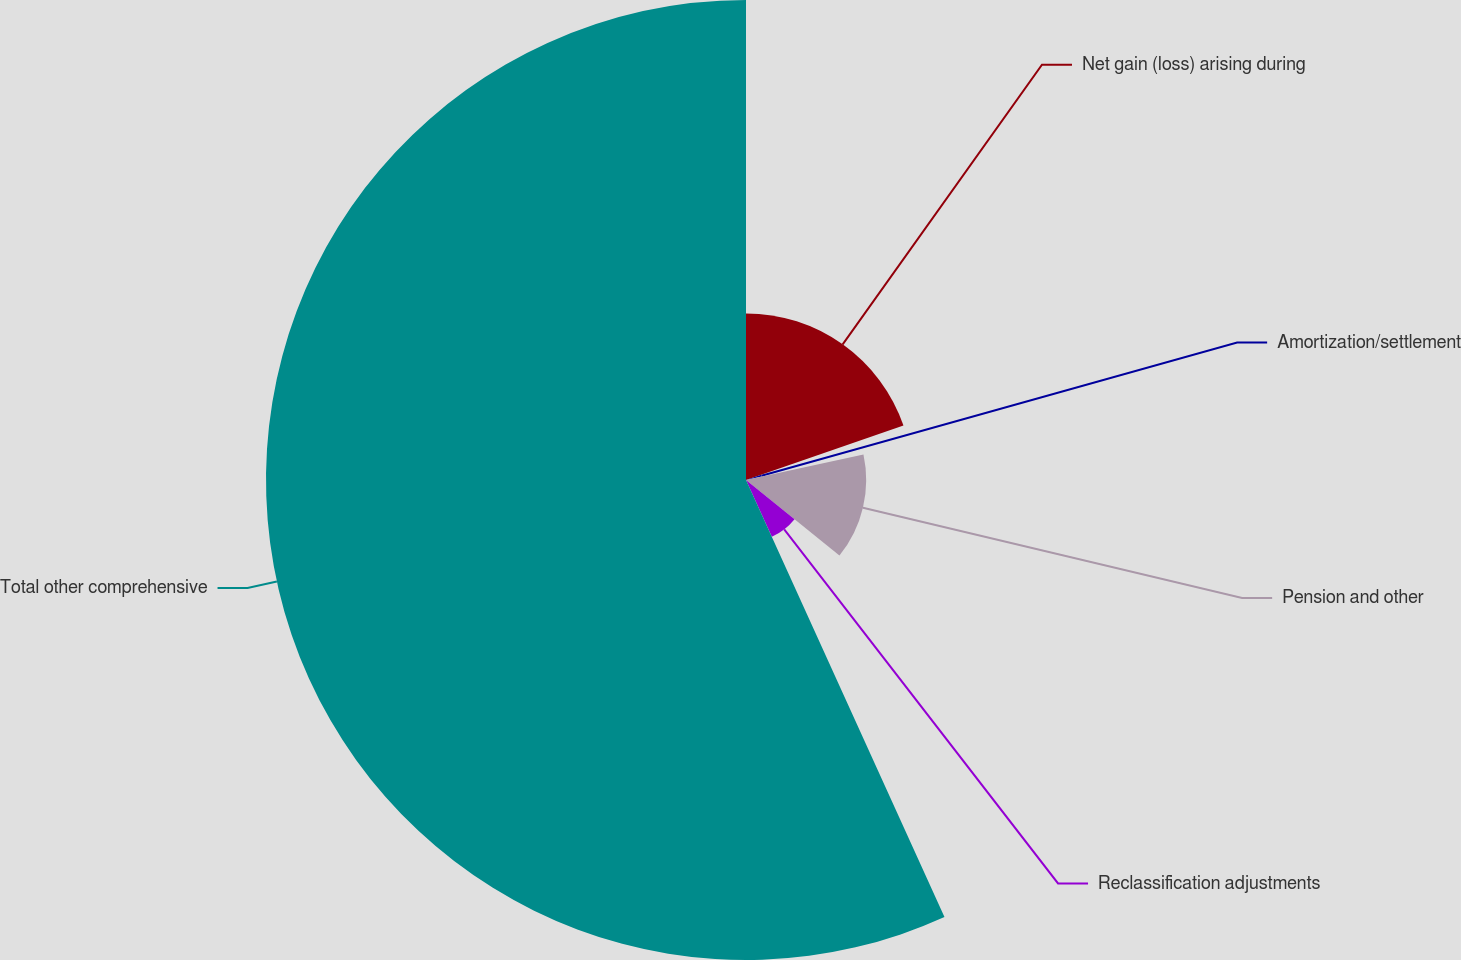Convert chart to OTSL. <chart><loc_0><loc_0><loc_500><loc_500><pie_chart><fcel>Net gain (loss) arising during<fcel>Amortization/settlement<fcel>Pension and other<fcel>Reclassification adjustments<fcel>Total other comprehensive<nl><fcel>19.71%<fcel>1.9%<fcel>14.22%<fcel>7.39%<fcel>56.79%<nl></chart> 